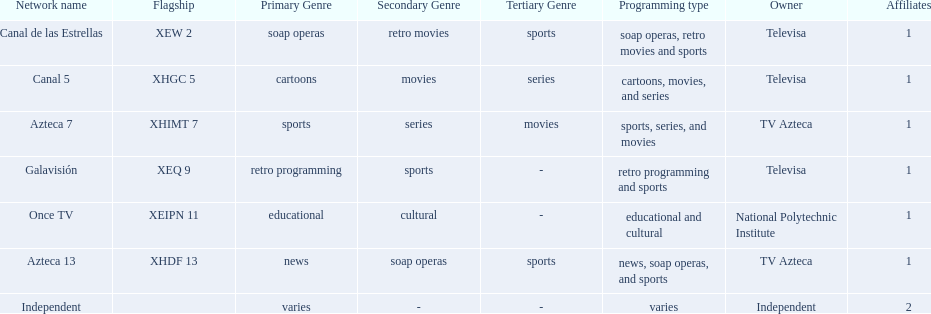What is the number of networks that are owned by televisa? 3. 